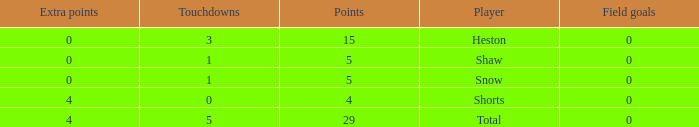What is the sum of all the touchdowns when the player had more than 0 extra points and less than 0 field goals? None. 